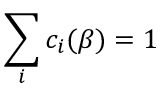Convert formula to latex. <formula><loc_0><loc_0><loc_500><loc_500>\sum _ { i } c _ { i } ( \beta ) = 1</formula> 